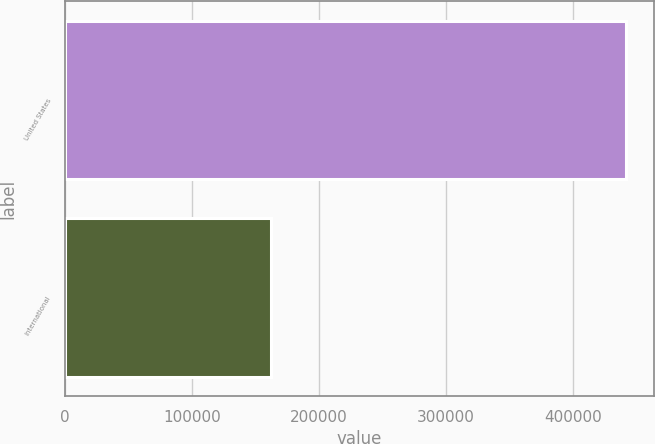<chart> <loc_0><loc_0><loc_500><loc_500><bar_chart><fcel>United States<fcel>International<nl><fcel>441336<fcel>162424<nl></chart> 